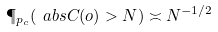Convert formula to latex. <formula><loc_0><loc_0><loc_500><loc_500>\P _ { p _ { c } } ( \ a b s { C ( o ) } > N ) \asymp N ^ { - 1 / 2 }</formula> 